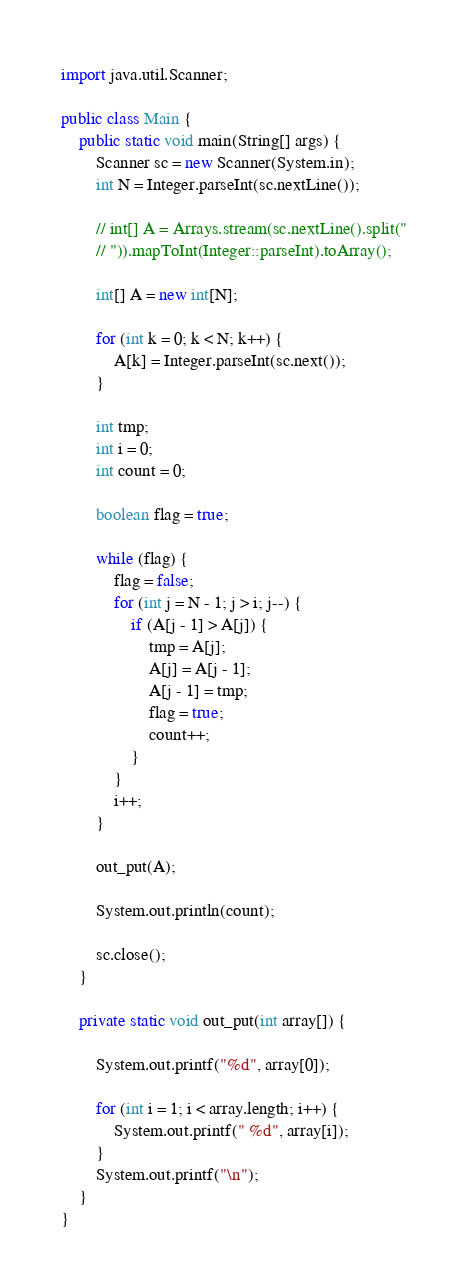Convert code to text. <code><loc_0><loc_0><loc_500><loc_500><_Java_>import java.util.Scanner;

public class Main {
	public static void main(String[] args) {
		Scanner sc = new Scanner(System.in);
		int N = Integer.parseInt(sc.nextLine());

		// int[] A = Arrays.stream(sc.nextLine().split("
		// ")).mapToInt(Integer::parseInt).toArray();

		int[] A = new int[N];

		for (int k = 0; k < N; k++) {
			A[k] = Integer.parseInt(sc.next());
		}

		int tmp;
		int i = 0;
		int count = 0;

		boolean flag = true;

		while (flag) {
			flag = false;
			for (int j = N - 1; j > i; j--) {
				if (A[j - 1] > A[j]) {
					tmp = A[j];
					A[j] = A[j - 1];
					A[j - 1] = tmp;
					flag = true;
					count++;
				}	
			}
			i++;
		}

		out_put(A);

		System.out.println(count);

		sc.close();
	}

	private static void out_put(int array[]) {

		System.out.printf("%d", array[0]);

		for (int i = 1; i < array.length; i++) {
			System.out.printf(" %d", array[i]);
		}
		System.out.printf("\n");
	}
}

</code> 